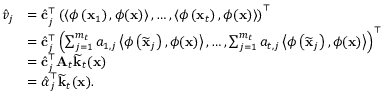Convert formula to latex. <formula><loc_0><loc_0><loc_500><loc_500>\begin{array} { r l } { \hat { v } _ { j } } & { = \hat { c } _ { j } ^ { \top } \left ( \left \langle \phi \left ( x _ { 1 } \right ) , \phi ( x ) \right \rangle , \dots , \left \langle \phi \left ( x _ { t } \right ) , \phi ( x ) \right \rangle \right ) ^ { \top } } \\ & { = \hat { c } _ { j } ^ { \top } \left ( \sum _ { j = 1 } ^ { m _ { t } } a _ { 1 , j } \left \langle \phi \left ( \widetilde { x } _ { j } \right ) , \phi ( x ) \right \rangle , \dots , \sum _ { j = 1 } ^ { m _ { t } } a _ { t , j } \left \langle \phi \left ( \widetilde { x } _ { j } \right ) , \phi ( x ) \right \rangle \right ) ^ { \top } } \\ & { = \hat { c } _ { j } ^ { \top } A _ { t } \widetilde { k } _ { t } ( x ) } \\ & { = \hat { \alpha } _ { j } ^ { \top } \widetilde { k } _ { t } ( x ) . } \end{array}</formula> 